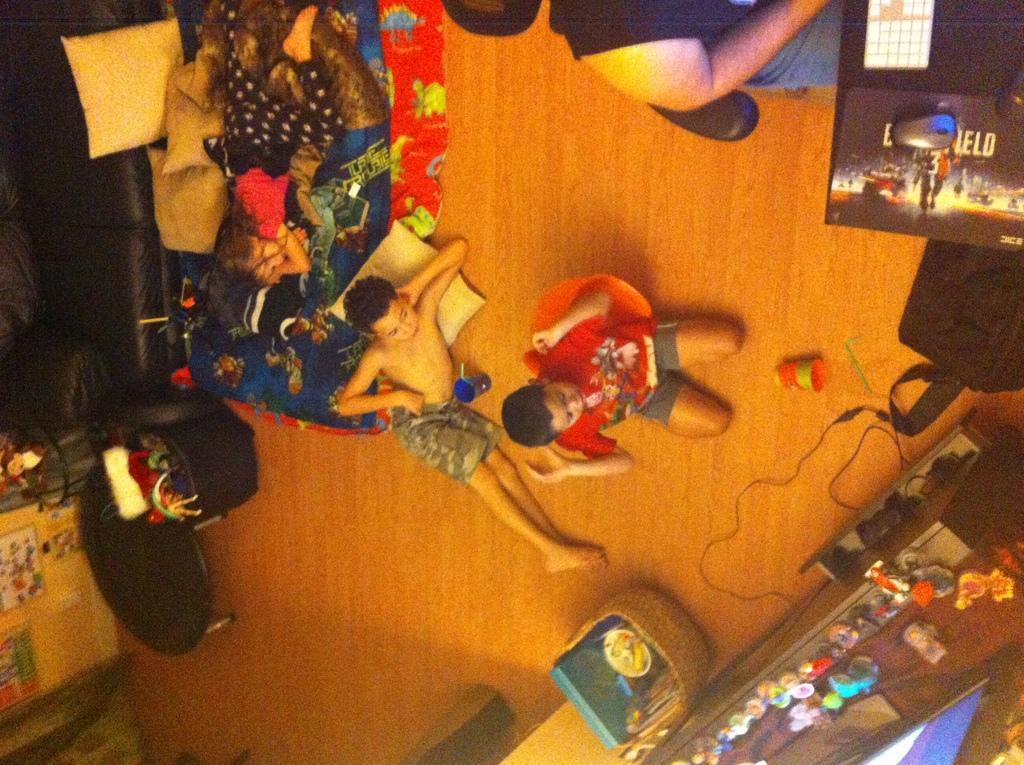Can you describe this image briefly? This image is taken from the top inside of a building, where we can see two boys on the floor and a girl sleeping on a bed and there is a man sitting on the chair near a table which includes mouse, mouse pad and a keyboard. This room also includes, cables, baskets, trampoline, black basket, pillows, glass, wall and few objects on the table. 